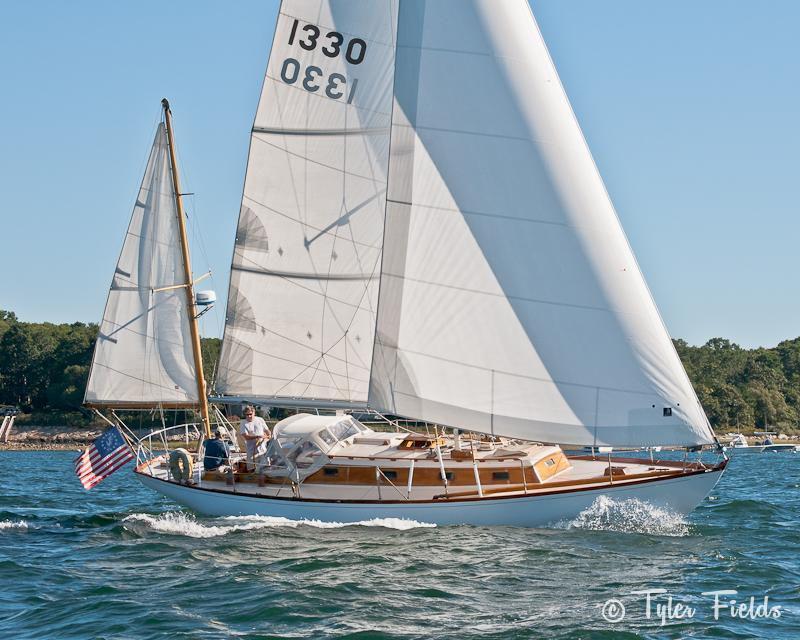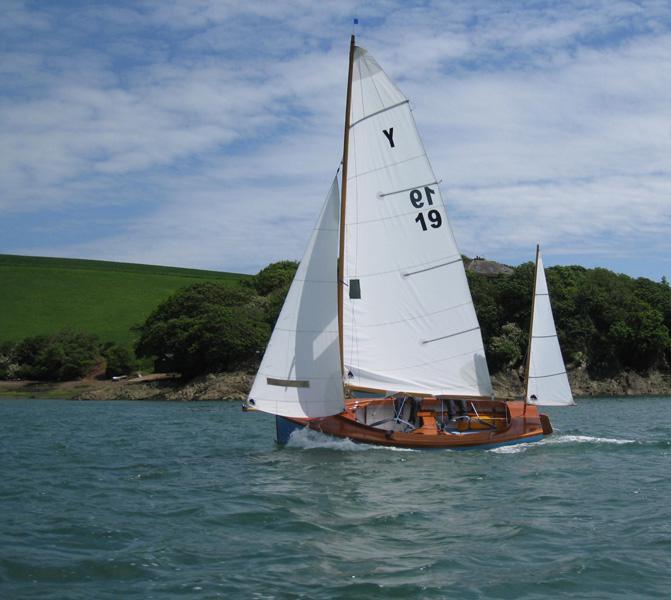The first image is the image on the left, the second image is the image on the right. Analyze the images presented: Is the assertion "There is atleast one boat with numbers or letters on the sail" valid? Answer yes or no. Yes. 